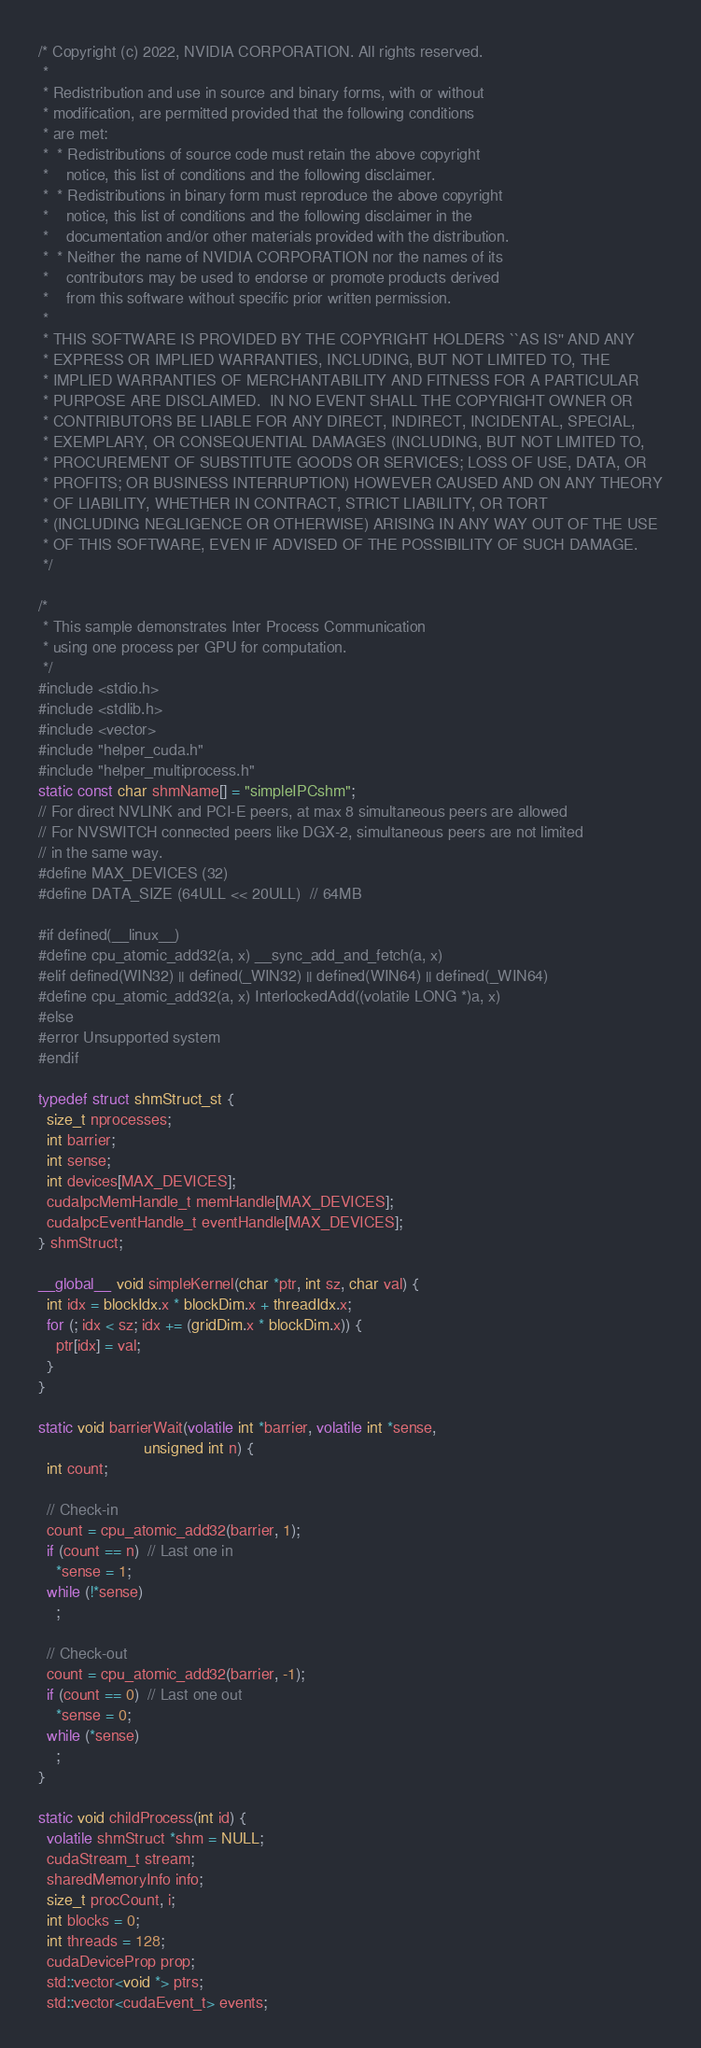Convert code to text. <code><loc_0><loc_0><loc_500><loc_500><_Cuda_>/* Copyright (c) 2022, NVIDIA CORPORATION. All rights reserved.
 *
 * Redistribution and use in source and binary forms, with or without
 * modification, are permitted provided that the following conditions
 * are met:
 *  * Redistributions of source code must retain the above copyright
 *    notice, this list of conditions and the following disclaimer.
 *  * Redistributions in binary form must reproduce the above copyright
 *    notice, this list of conditions and the following disclaimer in the
 *    documentation and/or other materials provided with the distribution.
 *  * Neither the name of NVIDIA CORPORATION nor the names of its
 *    contributors may be used to endorse or promote products derived
 *    from this software without specific prior written permission.
 *
 * THIS SOFTWARE IS PROVIDED BY THE COPYRIGHT HOLDERS ``AS IS'' AND ANY
 * EXPRESS OR IMPLIED WARRANTIES, INCLUDING, BUT NOT LIMITED TO, THE
 * IMPLIED WARRANTIES OF MERCHANTABILITY AND FITNESS FOR A PARTICULAR
 * PURPOSE ARE DISCLAIMED.  IN NO EVENT SHALL THE COPYRIGHT OWNER OR
 * CONTRIBUTORS BE LIABLE FOR ANY DIRECT, INDIRECT, INCIDENTAL, SPECIAL,
 * EXEMPLARY, OR CONSEQUENTIAL DAMAGES (INCLUDING, BUT NOT LIMITED TO,
 * PROCUREMENT OF SUBSTITUTE GOODS OR SERVICES; LOSS OF USE, DATA, OR
 * PROFITS; OR BUSINESS INTERRUPTION) HOWEVER CAUSED AND ON ANY THEORY
 * OF LIABILITY, WHETHER IN CONTRACT, STRICT LIABILITY, OR TORT
 * (INCLUDING NEGLIGENCE OR OTHERWISE) ARISING IN ANY WAY OUT OF THE USE
 * OF THIS SOFTWARE, EVEN IF ADVISED OF THE POSSIBILITY OF SUCH DAMAGE.
 */

/*
 * This sample demonstrates Inter Process Communication
 * using one process per GPU for computation.
 */
#include <stdio.h>
#include <stdlib.h>
#include <vector>
#include "helper_cuda.h"
#include "helper_multiprocess.h"
static const char shmName[] = "simpleIPCshm";
// For direct NVLINK and PCI-E peers, at max 8 simultaneous peers are allowed
// For NVSWITCH connected peers like DGX-2, simultaneous peers are not limited
// in the same way.
#define MAX_DEVICES (32)
#define DATA_SIZE (64ULL << 20ULL)  // 64MB

#if defined(__linux__)
#define cpu_atomic_add32(a, x) __sync_add_and_fetch(a, x)
#elif defined(WIN32) || defined(_WIN32) || defined(WIN64) || defined(_WIN64)
#define cpu_atomic_add32(a, x) InterlockedAdd((volatile LONG *)a, x)
#else
#error Unsupported system
#endif

typedef struct shmStruct_st {
  size_t nprocesses;
  int barrier;
  int sense;
  int devices[MAX_DEVICES];
  cudaIpcMemHandle_t memHandle[MAX_DEVICES];
  cudaIpcEventHandle_t eventHandle[MAX_DEVICES];
} shmStruct;

__global__ void simpleKernel(char *ptr, int sz, char val) {
  int idx = blockIdx.x * blockDim.x + threadIdx.x;
  for (; idx < sz; idx += (gridDim.x * blockDim.x)) {
    ptr[idx] = val;
  }
}

static void barrierWait(volatile int *barrier, volatile int *sense,
                        unsigned int n) {
  int count;

  // Check-in
  count = cpu_atomic_add32(barrier, 1);
  if (count == n)  // Last one in
    *sense = 1;
  while (!*sense)
    ;

  // Check-out
  count = cpu_atomic_add32(barrier, -1);
  if (count == 0)  // Last one out
    *sense = 0;
  while (*sense)
    ;
}

static void childProcess(int id) {
  volatile shmStruct *shm = NULL;
  cudaStream_t stream;
  sharedMemoryInfo info;
  size_t procCount, i;
  int blocks = 0;
  int threads = 128;
  cudaDeviceProp prop;
  std::vector<void *> ptrs;
  std::vector<cudaEvent_t> events;</code> 